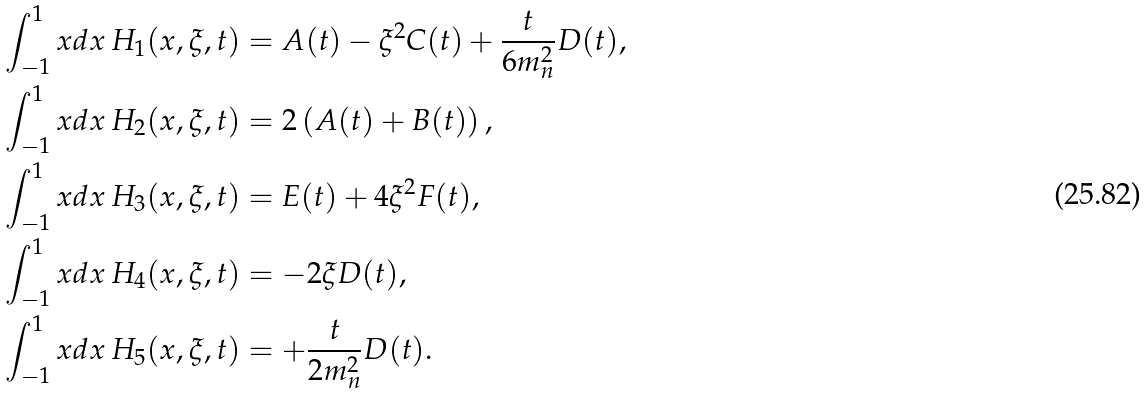<formula> <loc_0><loc_0><loc_500><loc_500>\int _ { - 1 } ^ { 1 } x d x \, H _ { 1 } ( x , \xi , t ) & = A ( t ) - \xi ^ { 2 } C ( t ) + \frac { t } { 6 m _ { n } ^ { 2 } } D ( t ) , \\ \int _ { - 1 } ^ { 1 } x d x \, H _ { 2 } ( x , \xi , t ) & = 2 \left ( A ( t ) + B ( t ) \right ) , \\ \int _ { - 1 } ^ { 1 } x d x \, H _ { 3 } ( x , \xi , t ) & = E ( t ) + 4 \xi ^ { 2 } F ( t ) , \\ \int _ { - 1 } ^ { 1 } x d x \, H _ { 4 } ( x , \xi , t ) & = - 2 \xi D ( t ) , \\ \int _ { - 1 } ^ { 1 } x d x \, H _ { 5 } ( x , \xi , t ) & = + \frac { t } { 2 m _ { n } ^ { 2 } } D ( t ) .</formula> 